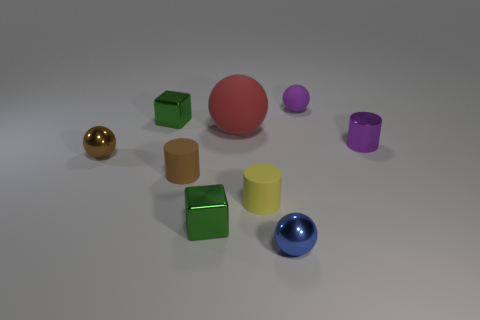Are the small purple cylinder and the tiny brown cylinder made of the same material?
Provide a succinct answer. No. There is a tiny cube that is behind the metallic ball on the left side of the big red ball; what number of blue shiny objects are behind it?
Your answer should be compact. 0. There is a metallic ball left of the tiny yellow object; what color is it?
Provide a succinct answer. Brown. What is the shape of the metal thing in front of the tiny green block that is to the right of the tiny brown rubber object?
Your response must be concise. Sphere. Does the big thing have the same color as the metal cylinder?
Provide a short and direct response. No. What number of spheres are tiny purple things or big red matte objects?
Provide a succinct answer. 2. There is a small sphere that is left of the small purple rubber ball and behind the blue shiny object; what is its material?
Your answer should be compact. Metal. What number of green metal cubes are in front of the small brown matte thing?
Offer a terse response. 1. Does the green cube in front of the yellow matte thing have the same material as the tiny cylinder behind the small brown metal object?
Ensure brevity in your answer.  Yes. How many things are either rubber balls that are to the left of the blue shiny sphere or tiny brown metallic things?
Your response must be concise. 2. 